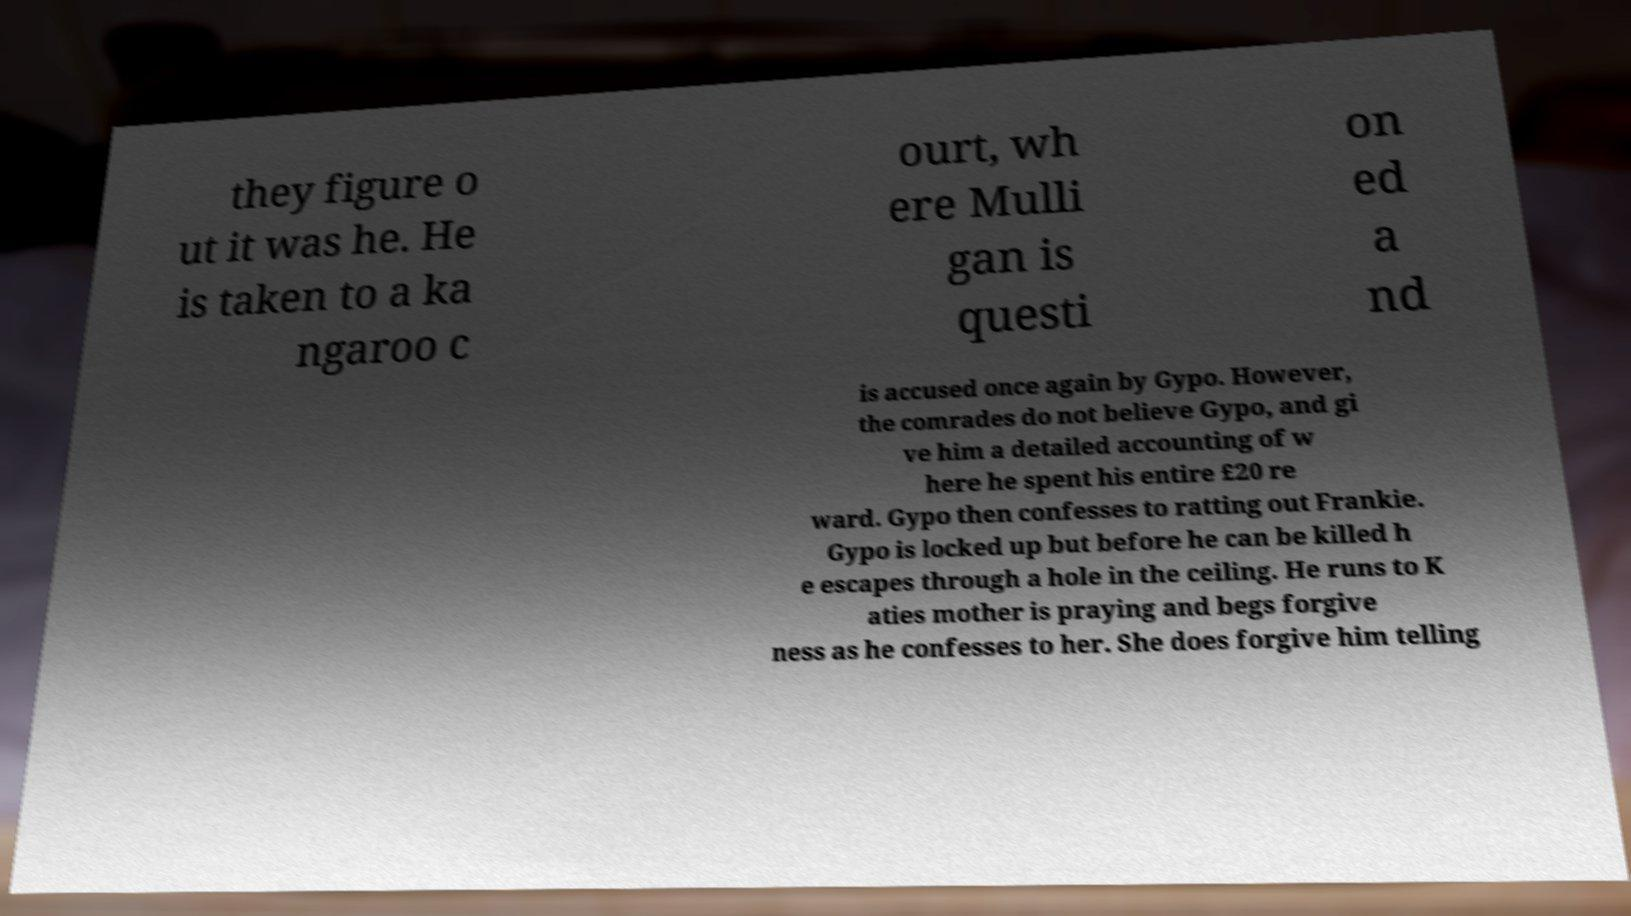What messages or text are displayed in this image? I need them in a readable, typed format. they figure o ut it was he. He is taken to a ka ngaroo c ourt, wh ere Mulli gan is questi on ed a nd is accused once again by Gypo. However, the comrades do not believe Gypo, and gi ve him a detailed accounting of w here he spent his entire £20 re ward. Gypo then confesses to ratting out Frankie. Gypo is locked up but before he can be killed h e escapes through a hole in the ceiling. He runs to K aties mother is praying and begs forgive ness as he confesses to her. She does forgive him telling 